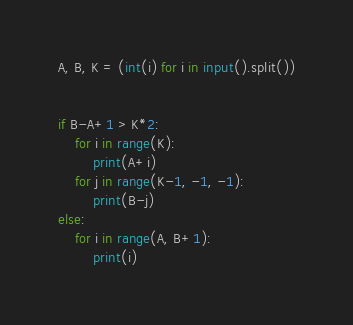Convert code to text. <code><loc_0><loc_0><loc_500><loc_500><_Python_>A, B, K = (int(i) for i in input().split())


if B-A+1 > K*2:
    for i in range(K):
        print(A+i)
    for j in range(K-1, -1, -1):
        print(B-j)
else:
    for i in range(A, B+1):
        print(i)
</code> 